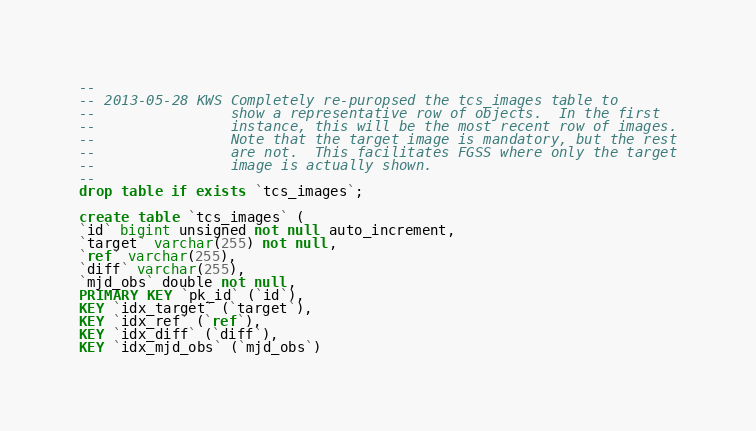Convert code to text. <code><loc_0><loc_0><loc_500><loc_500><_SQL_>--
-- 2013-05-28 KWS Completely re-puropsed the tcs_images table to
--                show a representative row of objects.  In the first
--                instance, this will be the most recent row of images.
--                Note that the target image is mandatory, but the rest
--                are not.  This facilitates FGSS where only the target
--                image is actually shown.
--
drop table if exists `tcs_images`;

create table `tcs_images` (
`id` bigint unsigned not null auto_increment,
`target` varchar(255) not null,
`ref` varchar(255),
`diff` varchar(255),
`mjd_obs` double not null,
PRIMARY KEY `pk_id` (`id`),
KEY `idx_target` (`target`),
KEY `idx_ref` (`ref`),
KEY `idx_diff` (`diff`),
KEY `idx_mjd_obs` (`mjd_obs`)</code> 